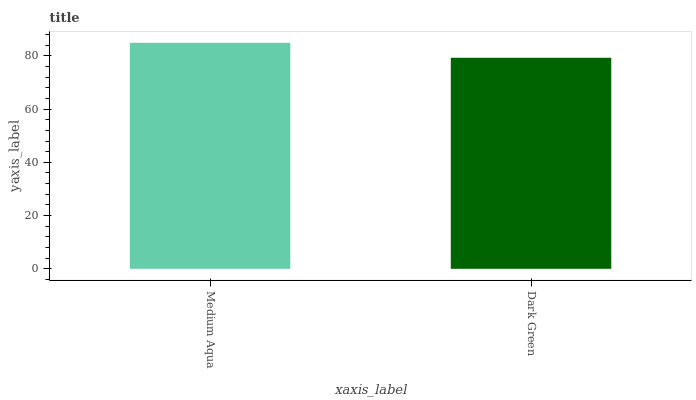Is Dark Green the minimum?
Answer yes or no. Yes. Is Medium Aqua the maximum?
Answer yes or no. Yes. Is Dark Green the maximum?
Answer yes or no. No. Is Medium Aqua greater than Dark Green?
Answer yes or no. Yes. Is Dark Green less than Medium Aqua?
Answer yes or no. Yes. Is Dark Green greater than Medium Aqua?
Answer yes or no. No. Is Medium Aqua less than Dark Green?
Answer yes or no. No. Is Medium Aqua the high median?
Answer yes or no. Yes. Is Dark Green the low median?
Answer yes or no. Yes. Is Dark Green the high median?
Answer yes or no. No. Is Medium Aqua the low median?
Answer yes or no. No. 